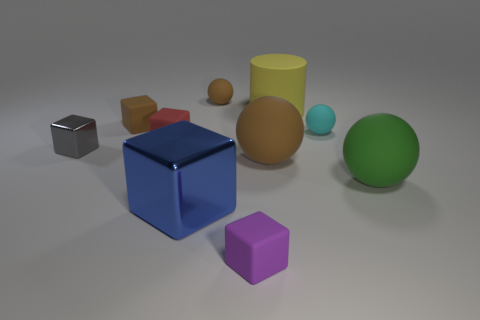How many red blocks are in front of the red object? There are no red blocks in front of the cylindrical red object. The arrangement of objects only includes one red object, which is cylindrical, and all blocks present are of different colors. 